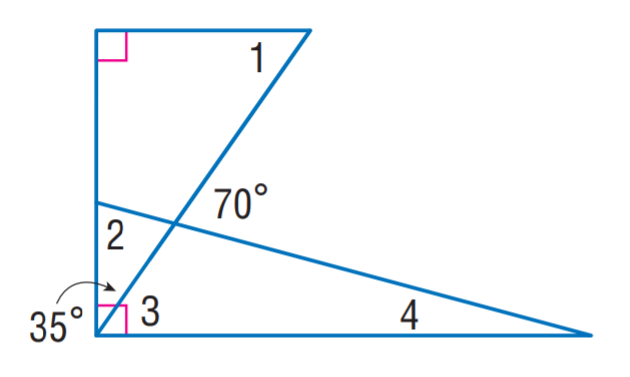Answer the mathemtical geometry problem and directly provide the correct option letter.
Question: Find m \angle 3.
Choices: A: 15 B: 35 C: 55 D: 75 C 